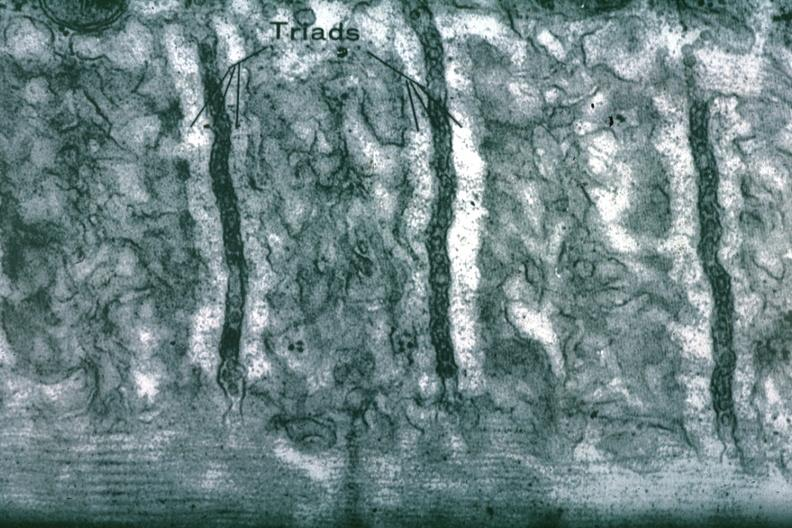what does this image show?
Answer the question using a single word or phrase. Sarcoplasmic reticulum 